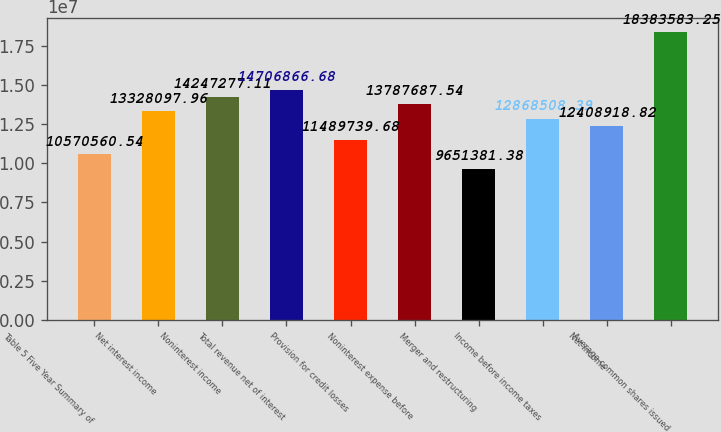<chart> <loc_0><loc_0><loc_500><loc_500><bar_chart><fcel>Table 5 Five Year Summary of<fcel>Net interest income<fcel>Noninterest income<fcel>Total revenue net of interest<fcel>Provision for credit losses<fcel>Noninterest expense before<fcel>Merger and restructuring<fcel>Income before income taxes<fcel>Net income<fcel>Average common shares issued<nl><fcel>1.05706e+07<fcel>1.33281e+07<fcel>1.42473e+07<fcel>1.47069e+07<fcel>1.14897e+07<fcel>1.37877e+07<fcel>9.65138e+06<fcel>1.28685e+07<fcel>1.24089e+07<fcel>1.83836e+07<nl></chart> 